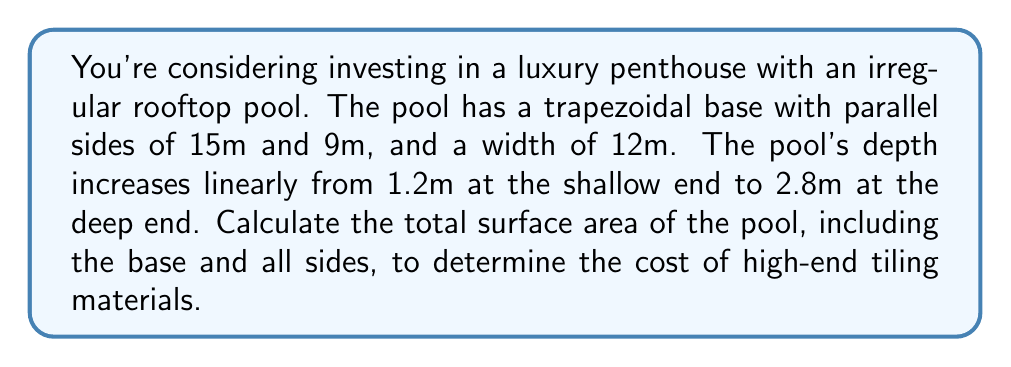Show me your answer to this math problem. Let's approach this step-by-step:

1) First, calculate the area of the trapezoidal base:
   $$A_{base} = \frac{(a+b)h}{2} = \frac{(15+9) \times 12}{2} = 144 \text{ m}^2$$

2) For the sides, we need to calculate their areas separately:

   a) The two parallel sides:
      Short side: $9 \times 1.2 = 10.8 \text{ m}^2$
      Long side: $15 \times 2.8 = 42 \text{ m}^2$

   b) The sloping sides:
      We need to find the length of the sloping side using the Pythagorean theorem:
      $$l = \sqrt{12^2 + (2.8-1.2)^2} = \sqrt{144 + 2.56} = \sqrt{146.56} \approx 12.11 \text{ m}$$
      
      Area of each sloping side: $12.11 \times \frac{15+9}{2} = 145.32 \text{ m}^2$

3) Sum up all the areas:
   $$A_{total} = A_{base} + A_{short} + A_{long} + 2A_{sloping}$$
   $$A_{total} = 144 + 10.8 + 42 + (2 \times 145.32) = 487.44 \text{ m}^2$$

Therefore, the total surface area of the pool is approximately 487.44 square meters.
Answer: 487.44 m² 